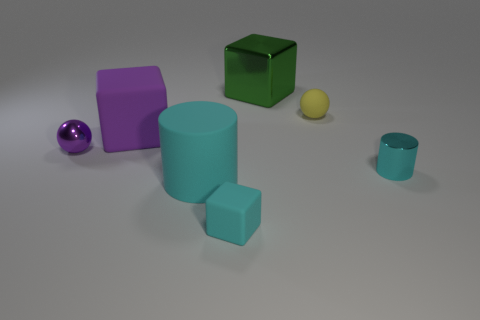How many things are either blocks that are behind the tiny purple object or cyan objects that are to the right of the rubber ball?
Your answer should be very brief. 3. What color is the big rubber object that is the same shape as the small cyan shiny thing?
Offer a terse response. Cyan. There is a tiny cyan rubber object; is it the same shape as the big object behind the small yellow rubber ball?
Keep it short and to the point. Yes. What material is the large green object?
Offer a terse response. Metal. The purple rubber object that is the same shape as the green shiny object is what size?
Make the answer very short. Large. How many other things are there of the same material as the purple sphere?
Your response must be concise. 2. Is the material of the green cube the same as the big purple block that is to the right of the tiny metallic sphere?
Your answer should be very brief. No. Are there fewer small rubber blocks that are behind the small shiny sphere than purple metallic objects that are in front of the green metallic cube?
Ensure brevity in your answer.  Yes. What is the color of the big thing that is behind the yellow sphere?
Offer a very short reply. Green. What number of other things are the same color as the big cylinder?
Provide a short and direct response. 2. 